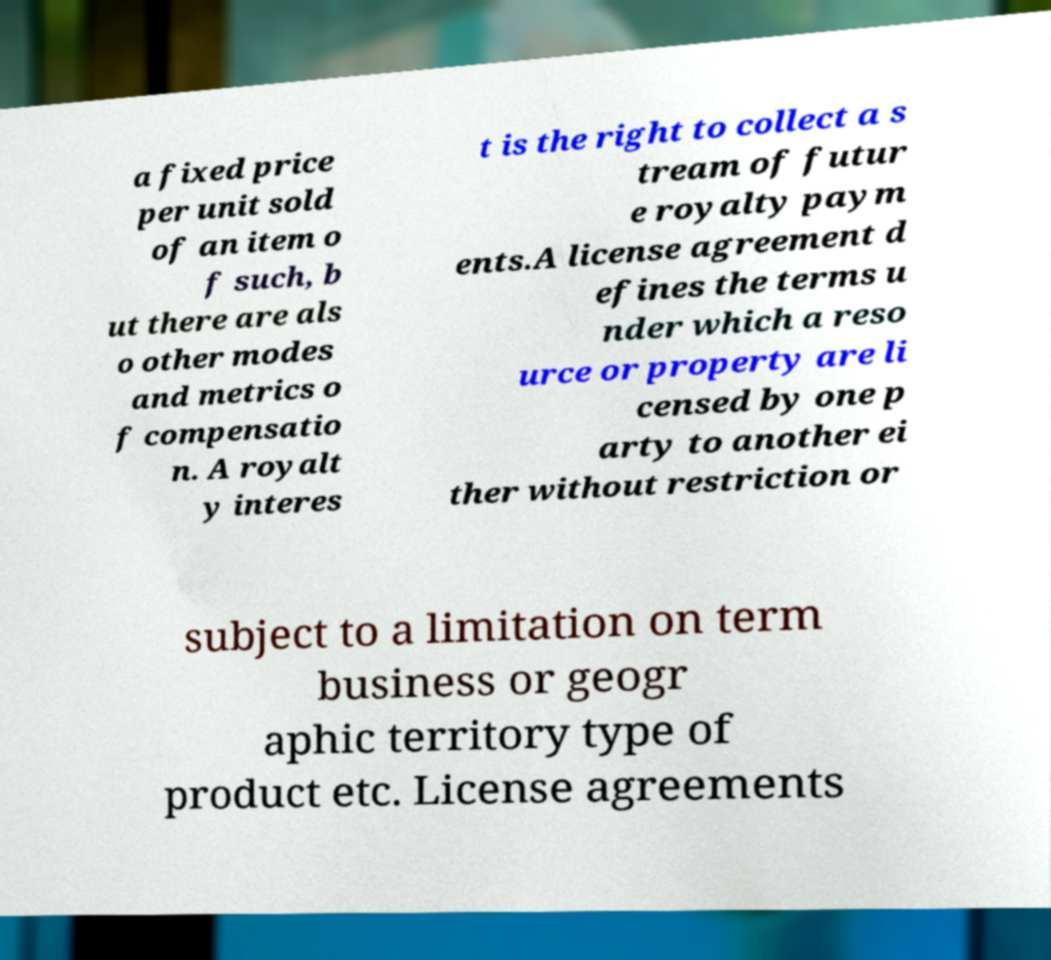For documentation purposes, I need the text within this image transcribed. Could you provide that? a fixed price per unit sold of an item o f such, b ut there are als o other modes and metrics o f compensatio n. A royalt y interes t is the right to collect a s tream of futur e royalty paym ents.A license agreement d efines the terms u nder which a reso urce or property are li censed by one p arty to another ei ther without restriction or subject to a limitation on term business or geogr aphic territory type of product etc. License agreements 